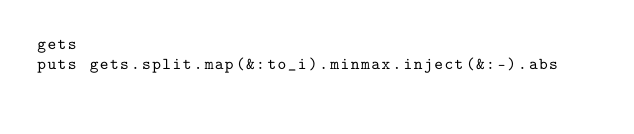Convert code to text. <code><loc_0><loc_0><loc_500><loc_500><_Ruby_>gets
puts gets.split.map(&:to_i).minmax.inject(&:-).abs</code> 